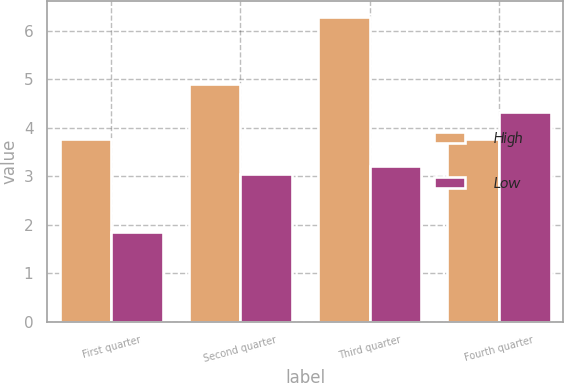<chart> <loc_0><loc_0><loc_500><loc_500><stacked_bar_chart><ecel><fcel>First quarter<fcel>Second quarter<fcel>Third quarter<fcel>Fourth quarter<nl><fcel>High<fcel>3.78<fcel>4.9<fcel>6.3<fcel>3.78<nl><fcel>Low<fcel>1.86<fcel>3.04<fcel>3.22<fcel>4.33<nl></chart> 